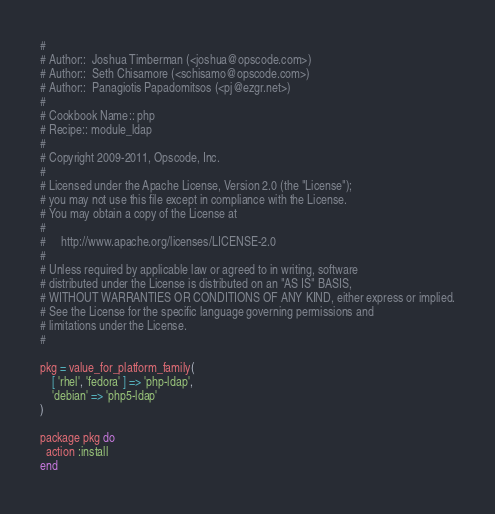Convert code to text. <code><loc_0><loc_0><loc_500><loc_500><_Ruby_>#
# Author::  Joshua Timberman (<joshua@opscode.com>)
# Author::  Seth Chisamore (<schisamo@opscode.com>)
# Author::  Panagiotis Papadomitsos (<pj@ezgr.net>)
#
# Cookbook Name:: php
# Recipe:: module_ldap
#
# Copyright 2009-2011, Opscode, Inc.
#
# Licensed under the Apache License, Version 2.0 (the "License");
# you may not use this file except in compliance with the License.
# You may obtain a copy of the License at
#
#     http://www.apache.org/licenses/LICENSE-2.0
#
# Unless required by applicable law or agreed to in writing, software
# distributed under the License is distributed on an "AS IS" BASIS,
# WITHOUT WARRANTIES OR CONDITIONS OF ANY KIND, either express or implied.
# See the License for the specific language governing permissions and
# limitations under the License.
#

pkg = value_for_platform_family(
    [ 'rhel', 'fedora' ] => 'php-ldap',
    'debian' => 'php5-ldap'
)

package pkg do
  action :install
end
</code> 